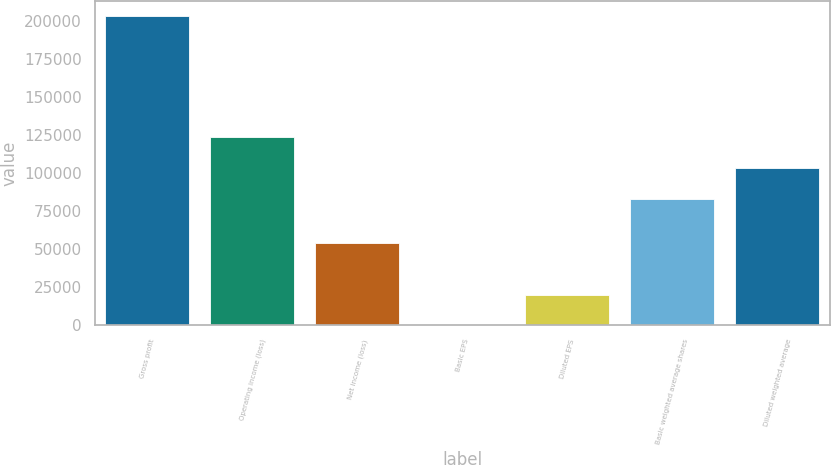<chart> <loc_0><loc_0><loc_500><loc_500><bar_chart><fcel>Gross profit<fcel>Operating income (loss)<fcel>Net income (loss)<fcel>Basic EPS<fcel>Diluted EPS<fcel>Basic weighted average shares<fcel>Diluted weighted average<nl><fcel>203113<fcel>123802<fcel>54351<fcel>0.65<fcel>20311.9<fcel>83180<fcel>103491<nl></chart> 